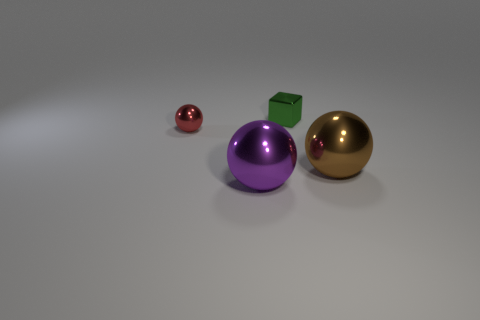Is there anything else that has the same shape as the small green shiny thing?
Keep it short and to the point. No. Do the green metallic thing and the ball to the right of the green metallic block have the same size?
Keep it short and to the point. No. Is the number of purple metallic spheres behind the red shiny object less than the number of large shiny balls to the right of the big purple metallic thing?
Ensure brevity in your answer.  Yes. What size is the purple metal thing that is on the left side of the brown object?
Make the answer very short. Large. Do the green shiny block and the brown ball have the same size?
Ensure brevity in your answer.  No. How many metal things are both right of the red metal ball and to the left of the brown shiny sphere?
Your response must be concise. 2. How many blue things are shiny spheres or big metallic balls?
Your answer should be compact. 0. What number of shiny objects are purple cubes or brown things?
Offer a very short reply. 1. Are any purple objects visible?
Ensure brevity in your answer.  Yes. Is the tiny red metal thing the same shape as the purple metal object?
Ensure brevity in your answer.  Yes. 